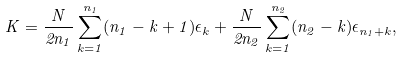Convert formula to latex. <formula><loc_0><loc_0><loc_500><loc_500>K = \frac { N } { 2 n _ { 1 } } \sum _ { k = 1 } ^ { n _ { 1 } } ( n _ { 1 } - k + 1 ) \epsilon _ { k } + \frac { N } { 2 n _ { 2 } } \sum _ { k = 1 } ^ { n _ { 2 } } ( n _ { 2 } - k ) \epsilon _ { n _ { 1 } + k } ,</formula> 